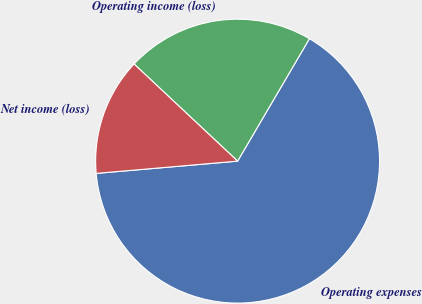Convert chart. <chart><loc_0><loc_0><loc_500><loc_500><pie_chart><fcel>Operating expenses<fcel>Operating income (loss)<fcel>Net income (loss)<nl><fcel>65.18%<fcel>21.45%<fcel>13.37%<nl></chart> 